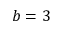Convert formula to latex. <formula><loc_0><loc_0><loc_500><loc_500>b = 3</formula> 